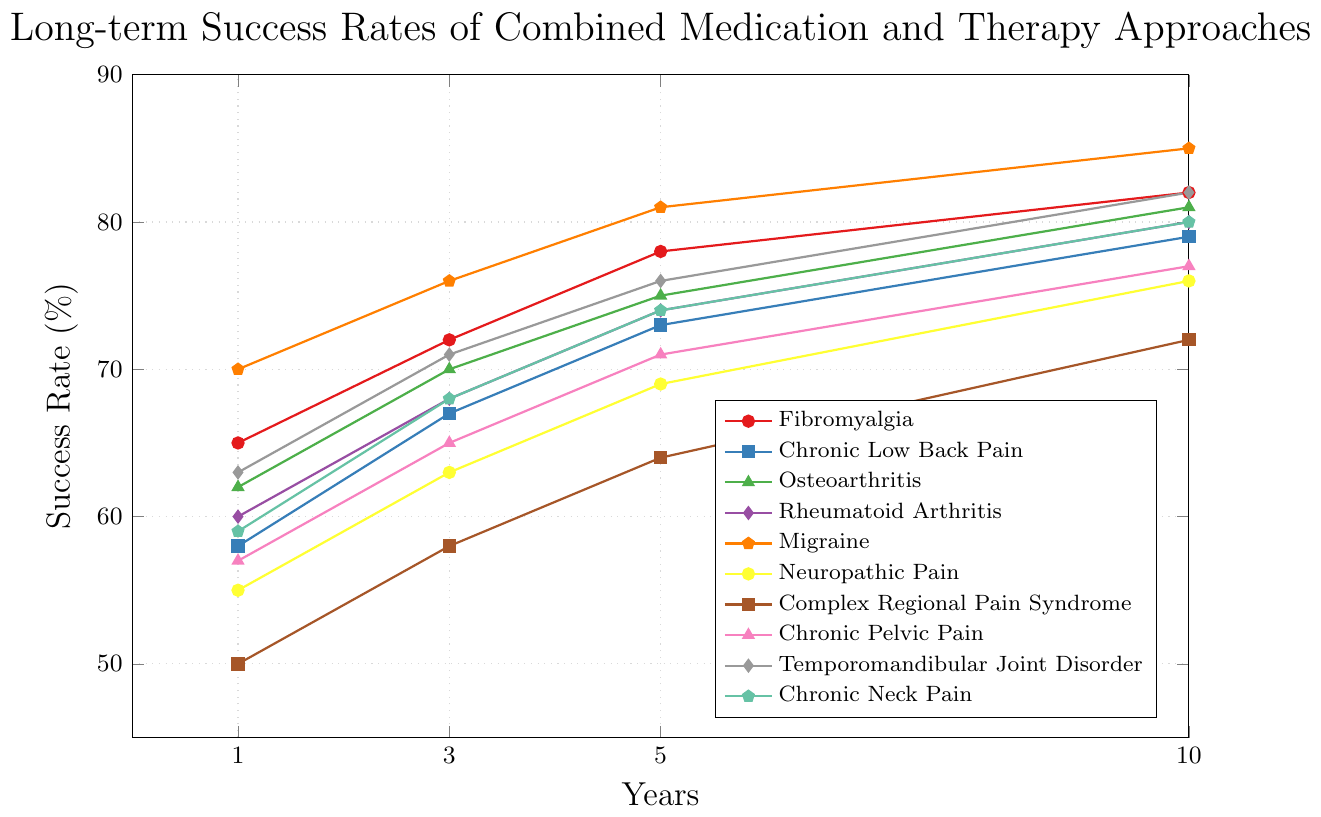What is the success rate of Chronic Low Back Pain at 5 years? The figure indicates that the success rate for Chronic Low Back Pain at the 5-year mark is represented by the blue-colored line with square markers. Locate the 5-year tick on the x-axis and follow the corresponding blue line upwards to see the success rate value, which is 73%
Answer: 73% What chronic pain condition has the highest success rate at 10 years? To find the highest success rate at 10 years, look at the rightmost values (x=10) of all lines and identify the one with the highest y-value. The success rate for Migraine at 10 years is the highest at 85%
Answer: Migraine Which condition has a lower success rate at 3 years, Rheumatoid Arthritis or Chronic Pelvic Pain? Compare the success rates of Rheumatoid Arthritis and Chronic Pelvic Pain at the 3-year mark by looking at their respective lines. Rheumatoid Arthritis (purple line with diamond markers) has a rate of 68%, and Chronic Pelvic Pain (pink line with triangle markers) has a rate of 65%. Rheumatoid Arthritis has a higher rate, so Chronic Pelvic Pain is lower
Answer: Chronic Pelvic Pain What is the average success rate of Fibromyalgia over 1, 3, and 5 years? Calculate the average success rate by summing the values for Fibromyalgia at 1, 3, and 5 years, and then dividing by 3: (65+72+78)/3 = 215/3 = 71.67
Answer: 71.67 Which condition shows the greatest increase in success rate from 1 to 10 years? To determine this, calculate the difference between the 10-year and 1-year success rates for each condition and find the largest difference. For Migraine: 85-70=15; for Complex Regional Pain Syndrome: 72-50=22; Upon calculating, it is seen that Complex Regional Pain Syndrome has the greatest increase
Answer: Complex Regional Pain Syndrome How do the success rates of Neuropathic Pain compare to Chronic Neck Pain at 5 and 10 years? Neuropathic Pain has a success rate of 69% at 5 years and 76% at 10 years, while Chronic Neck Pain has a success rate of 74% at 5 years and 80% at 10 years. Chronic Neck Pain has higher success rates at both 5 and 10 years
Answer: Chronic Neck Pain is higher at both 5 and 10 years What is the overall trend for success rates in both Chronic Low Back Pain and Osteoarthritis over time? Both conditions show an increasing trend in success rates over time. Chronic Low Back Pain (blue line with square markers) and Osteoarthritis (green line with triangle markers) both increase steadily from 1 to 10 years. This indicates improving success rates with extended treatment time.
Answer: Increasing trend What is the difference in success rate between Neuropathic Pain and Complex Regional Pain Syndrome at the 10-year mark? At 10 years, Neuropathic Pain has a success rate of 76%, and Complex Regional Pain Syndrome has a success rate of 72%. The difference is calculated as 76-72 = 4
Answer: 4 Which condition has the closest success rate to 70% at the 3-year mark? At the 3-year mark, compare the success rates of all conditions to 70%: Fibromyalgia (72%), Chronic Low Back Pain (67%), Rheumatoid Arthritis (68%), and Osteoarthritis (70%). Osteoarthritis is exactly at 70%
Answer: Osteoarthritis What is the success rate of Temporomandibular Joint Disorder at 1 year and how does it compare to Fibromyalgia at the same time point? According to the figure, the success rate of Temporomandibular Joint Disorder at 1 year is 63% (gray line with diamond markers), while Fibromyalgia at 1 year is 65% (red line with circle markers). Temporomandibular Joint Disorder has a lower success rate
Answer: Temporomandibular Joint Disorder is lower 